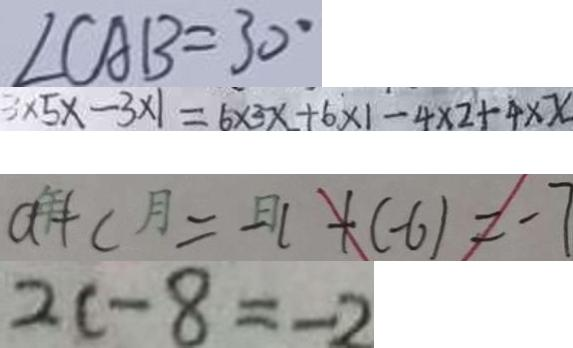<formula> <loc_0><loc_0><loc_500><loc_500>\angle C A B = 3 0 ^ { \circ } 
 3 \times 5 x - 3 \times 1 = 6 \times 3 x + 6 \times 1 - 4 \times 2 + 4 \times x 
 a + b = - 1 + ( - 6 ) = - 7 
 2 c - 8 = - 2</formula> 